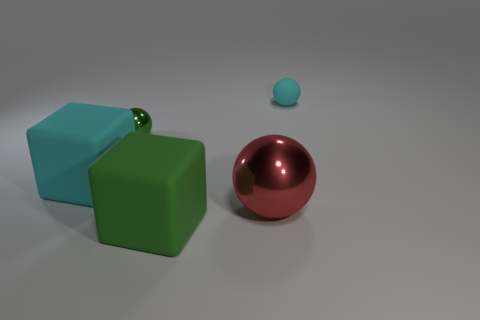What is the tiny green ball made of?
Your response must be concise. Metal. How many rubber things are the same shape as the green shiny thing?
Ensure brevity in your answer.  1. What material is the other thing that is the same color as the tiny metal thing?
Keep it short and to the point. Rubber. What color is the big block that is to the left of the rubber block on the right side of the cyan thing that is on the left side of the cyan ball?
Give a very brief answer. Cyan. How many tiny things are either blocks or spheres?
Your response must be concise. 2. Are there the same number of cyan matte blocks that are in front of the large green object and rubber balls?
Offer a very short reply. No. There is a big red sphere; are there any tiny metal things left of it?
Ensure brevity in your answer.  Yes. What number of matte objects are either brown balls or green things?
Offer a very short reply. 1. What number of large objects are on the left side of the large metallic object?
Your response must be concise. 2. Are there any yellow blocks of the same size as the red object?
Make the answer very short. No. 